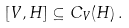Convert formula to latex. <formula><loc_0><loc_0><loc_500><loc_500>[ V , H ] \subseteq C _ { V } ( H ) \, .</formula> 